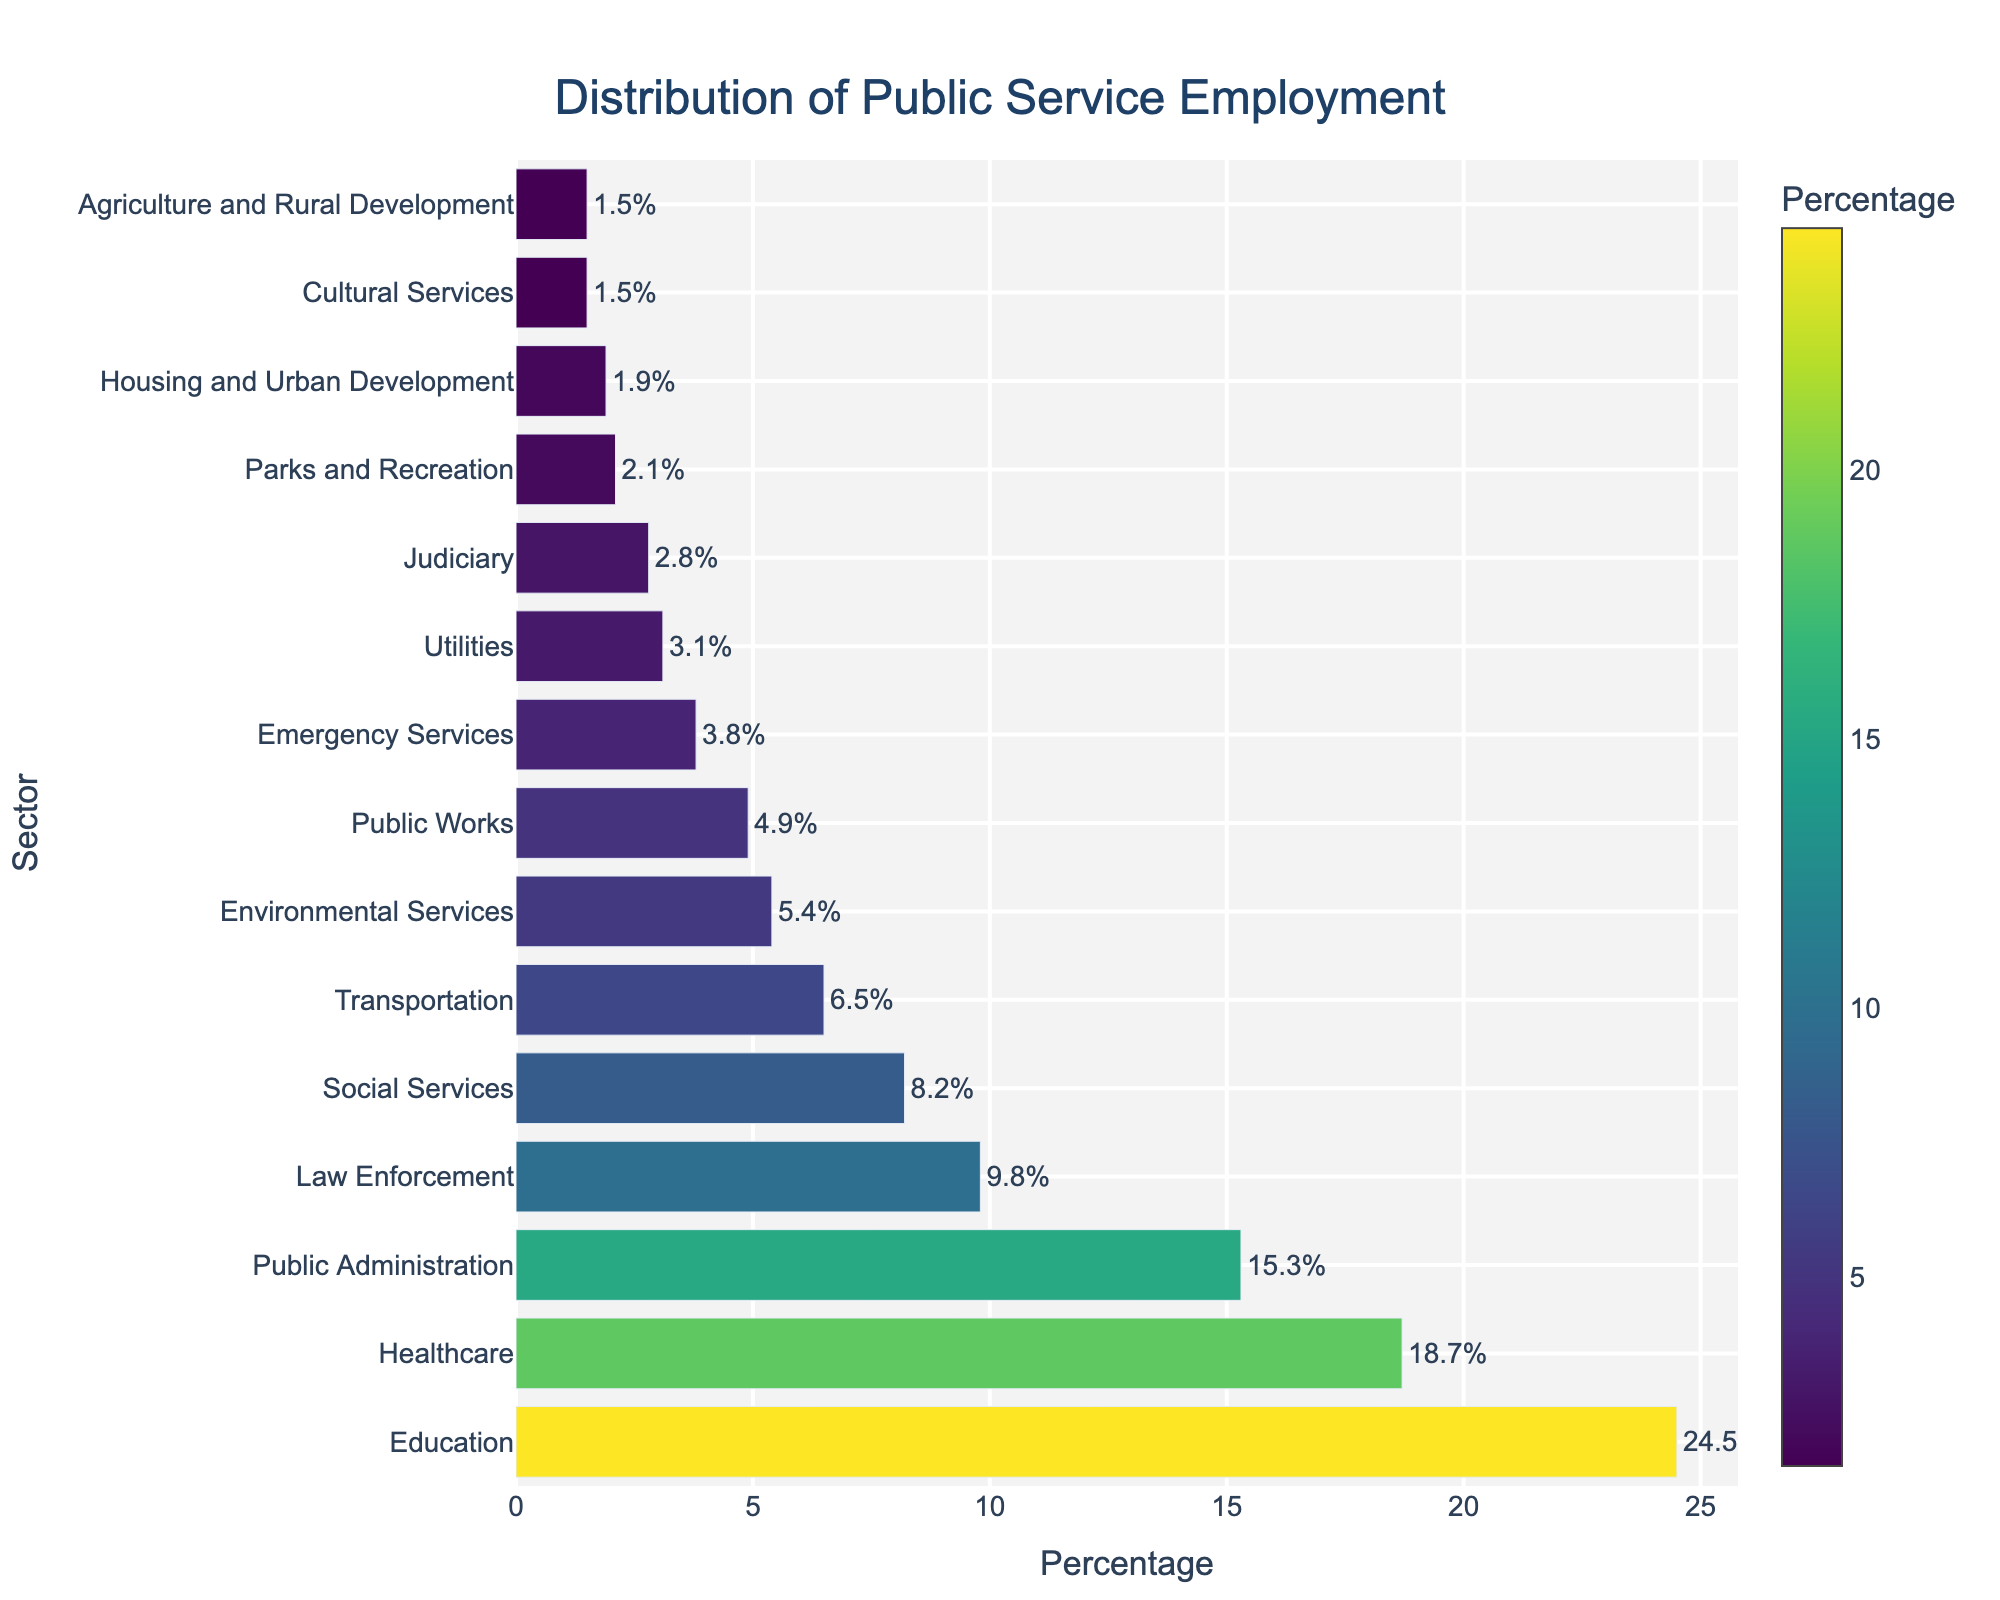Which sector has the highest percentage of public service employment? The highest bar on the chart corresponds to the Education sector, which indicates it has the highest percentage.
Answer: Education What is the difference between the percentages of Healthcare and Public Administration sectors? Healthcare has a percentage of 18.7, and Public Administration has 15.3. The difference is calculated as 18.7 - 15.3 = 3.4.
Answer: 3.4% Which sector has a higher percentage, Law Enforcement or Transportation? Comparing the two bars, Law Enforcement is higher with 9.8% compared to Transportation with 6.5%.
Answer: Law Enforcement How much more percentage does the Education sector have compared to Emergency Services? Education has 24.5% and Emergency Services have 3.8%. The difference is 24.5 - 3.8 = 20.7.
Answer: 20.7% What is the combined percentage of Environmental Services, Public Works, and Utilities sectors? Add the percentages of the three sectors: 5.4 (Environmental Services) + 4.9 (Public Works) + 3.1 (Utilities) = 13.4.
Answer: 13.4% Which sector has the smallest percentage, and what is it? The smallest bar corresponds to Agriculture and Rural Development and Cultural Services, both with 1.5%.
Answer: Agriculture and Rural Development, Cultural Services (1.5%) Compare the percentages between the Social Services and Housing and Urban Development sectors. Which is greater and by how much? Social Services is at 8.2% while Housing and Urban Development is at 1.9%. The difference is 8.2 - 1.9 = 6.3.
Answer: Social Services by 6.3% What is the median sector in terms of public service employment percentage? Arrange the percentages in order and find the middle value(s). With 15 sectors here, the median is the 8th value: Emergency Services (3.8%).
Answer: Emergency Services How many sectors have a percentage higher than 10%? By looking at the bars higher than 10%, we have Education, Healthcare, and Public Administration.
Answer: 3 sectors What is the percentage difference between the highest and lowest sectors? The highest is Education with 24.5%, and the lowest is 1.5% (Agriculture and Rural Development, Cultural Services). The difference is 24.5 - 1.5 = 23.0.
Answer: 23.0% 